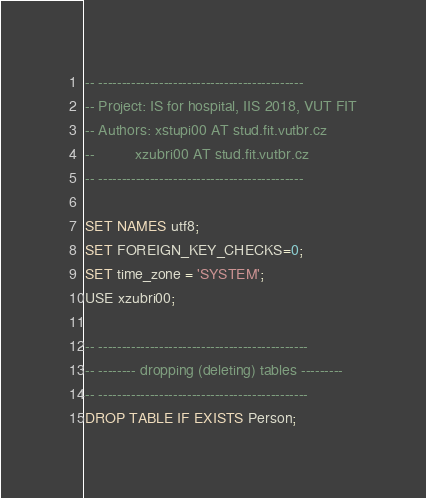<code> <loc_0><loc_0><loc_500><loc_500><_SQL_>-- --------------------------------------------
-- Project: IS for hospital, IIS 2018, VUT FIT
-- Authors: xstupi00 AT stud.fit.vutbr.cz
--          xzubri00 AT stud.fit.vutbr.cz
-- --------------------------------------------

SET NAMES utf8;
SET FOREIGN_KEY_CHECKS=0;
SET time_zone = 'SYSTEM';
USE xzubri00;

-- ---------------------------------------------
-- -------- dropping (deleting) tables ---------
-- ---------------------------------------------
DROP TABLE IF EXISTS Person;</code> 